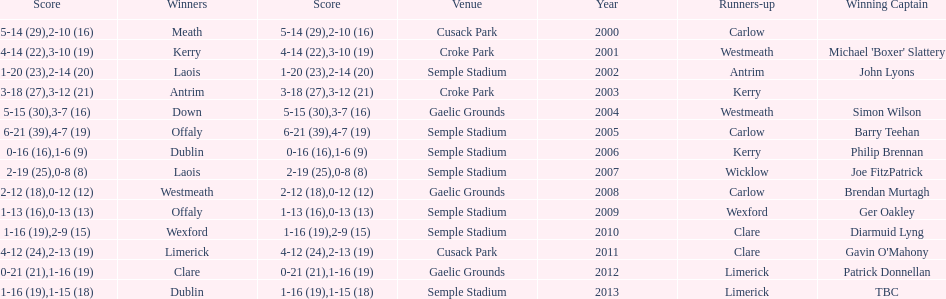Which was the inaugural team to secure a win led by a team captain? Kerry. 